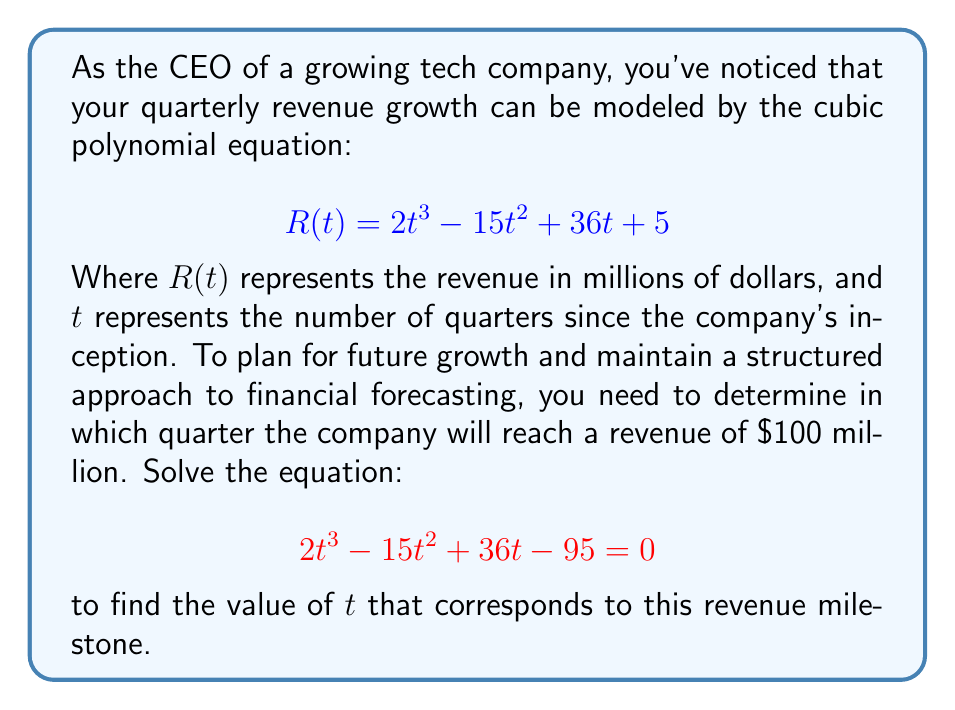Give your solution to this math problem. To solve this cubic equation, we'll follow these steps:

1) First, we need to factor out the greatest common factor (GCF):
   $$2t^3 - 15t^2 + 36t - 95 = 0$$
   There is no common factor, so we move to the next step.

2) Check if there's a rational root. We can use the rational root theorem. The possible rational roots are the factors of the constant term (95) divided by the factors of the leading coefficient (2):
   $\pm 1, \pm 5, \pm 19, \pm 95, \pm \frac{1}{2}, \pm \frac{5}{2}, \pm \frac{19}{2}, \pm \frac{95}{2}$

3) Let's test these values. We find that $t = 5$ is a root:
   $$2(5)^3 - 15(5)^2 + 36(5) - 95 = 250 - 375 + 180 - 95 = -40 + 40 = 0$$

4) Now we can factor out $(t - 5)$:
   $$2t^3 - 15t^2 + 36t - 95 = (t - 5)(2t^2 - 5t + 19) = 0$$

5) The quadratic factor $2t^2 - 5t + 19$ can't be factored further as it has no real roots (its discriminant is negative).

6) Therefore, the only real solution to this equation is $t = 5$.

This means the company will reach a revenue of $100 million in the 5th quarter since inception.
Answer: The company will reach a revenue of $100 million in the 5th quarter $(t = 5)$. 